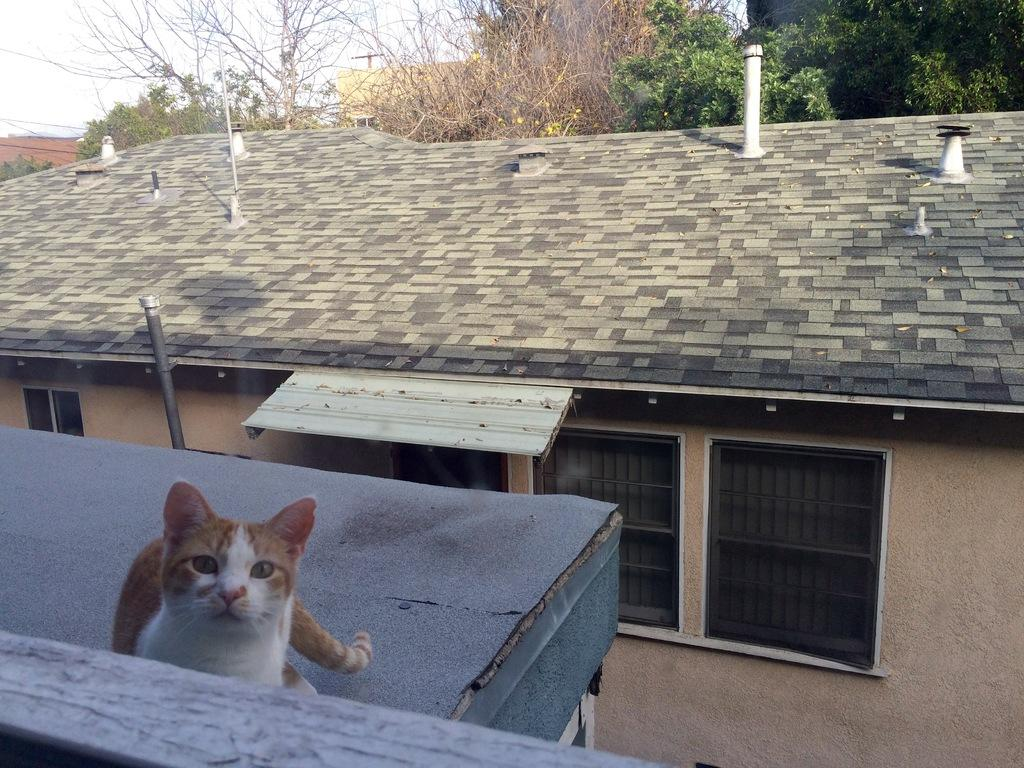What type of structures can be seen in the image? There are buildings in the image. What other elements are present in the image besides buildings? There are trees in the image. Is there any animal visible in the image? Yes, there is a cat in the image. Can you describe the appearance of the cat? The cat is white and brown in color. How would you describe the weather based on the image? The sky is cloudy in the image. How many eggs are the cat's daughter carrying in the image? There is no cat's daughter or eggs present in the image. 